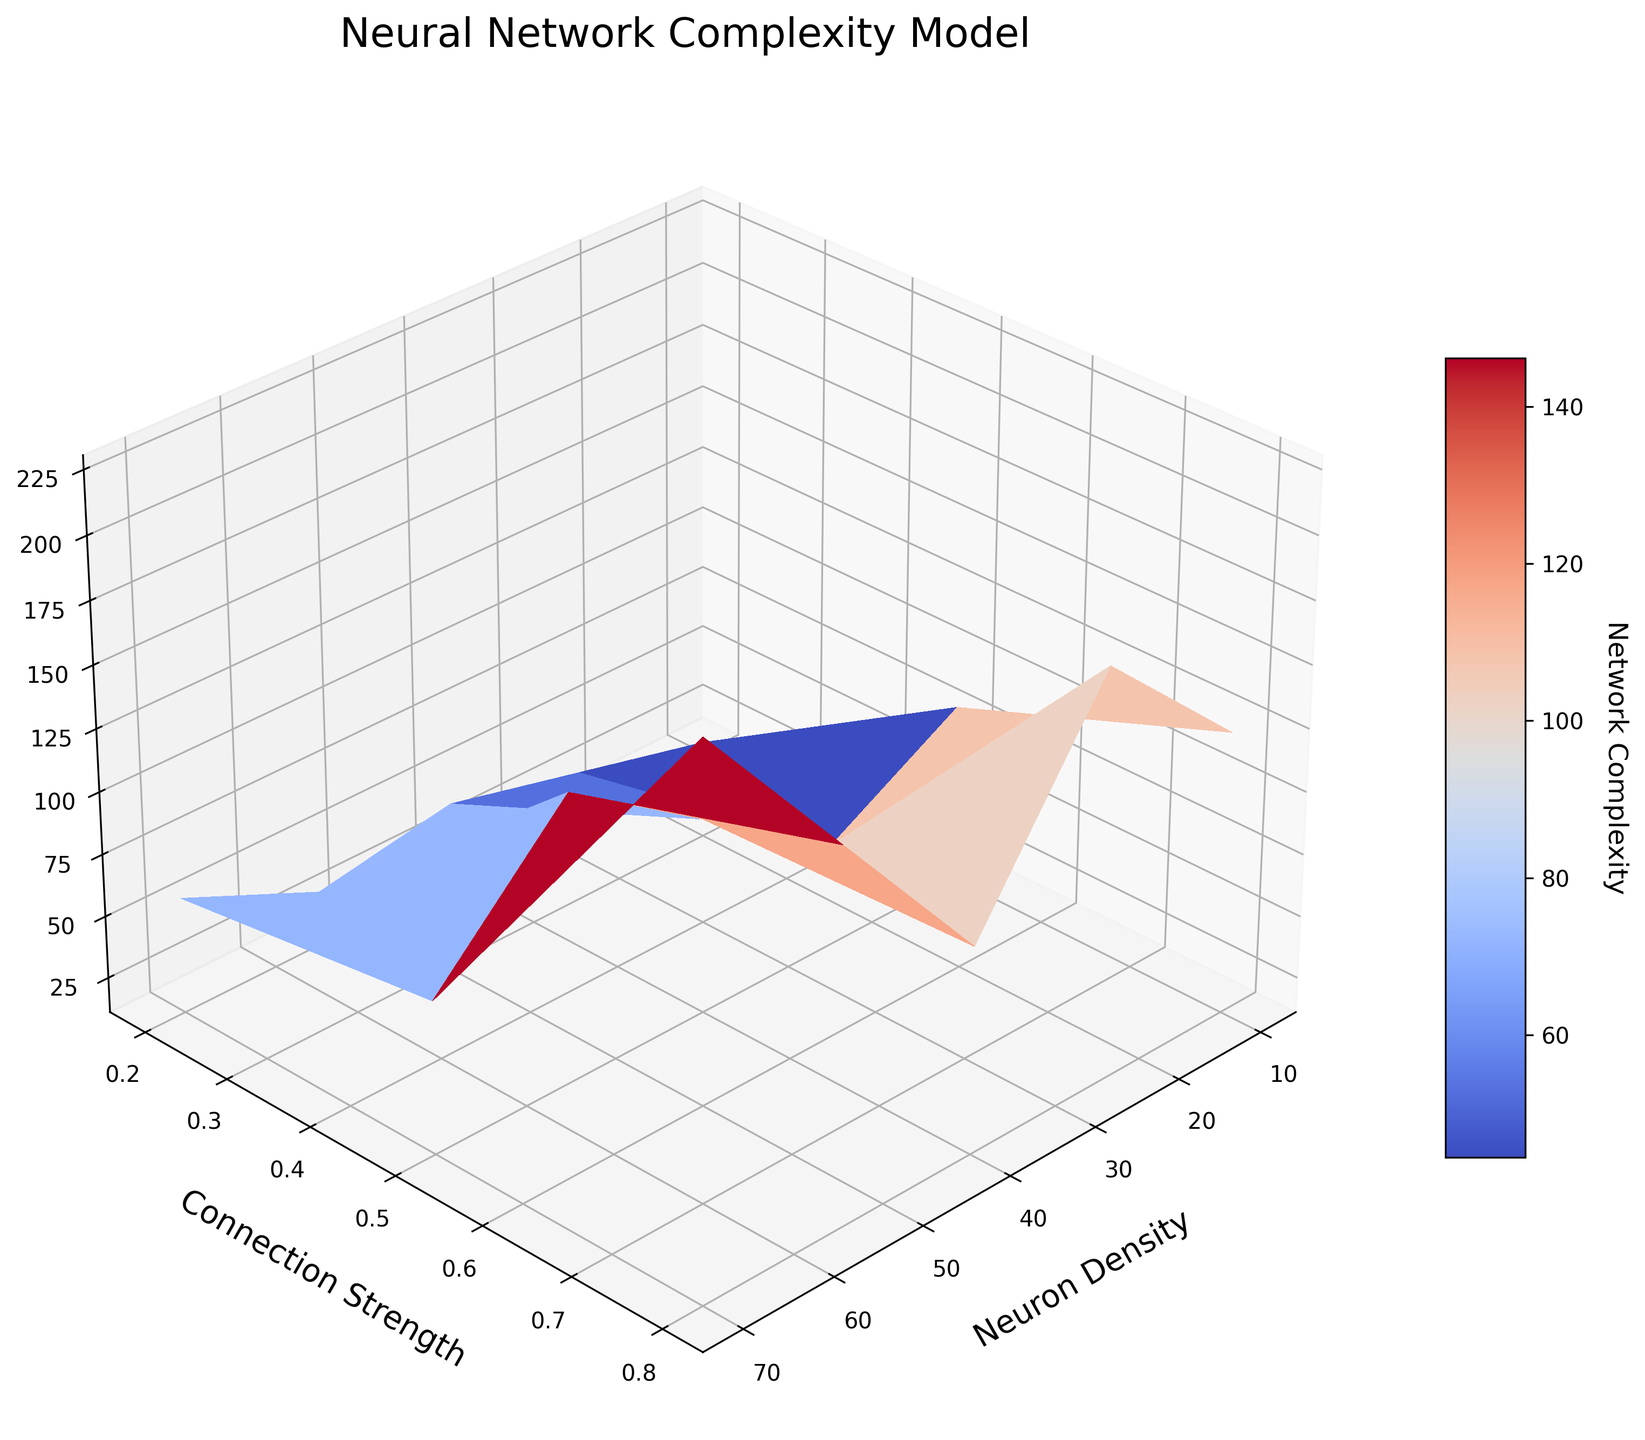What is the title of the figure? The title of a figure is usually displayed prominently at the top of the plot. Here, it reads 'Neural Network Complexity Model' as stated in the code.
Answer: Neural Network Complexity Model What do the X, Y, and Z axes represent in the plot? The axes are labeled. The X axis is labeled 'Neuron Density', the Y axis is labeled 'Connection Strength', and the Z axis is labeled 'Network Complexity'.
Answer: Neuron Density, Connection Strength, Network Complexity Which combination of Neuron Density and Connection Strength results in the highest Network Complexity? By examining the surface plot's highest value, the combination (70, 0.8) yields the highest Network Complexity, indicated by the peak at these coordinates.
Answer: (70, 0.8) How does increasing the Neuron Density, while keeping the Connection Strength constant, affect the Network Complexity? Observe the surface plot's elevation changes along the X direction while keeping Y constant. The plot shows that Network Complexity increases with Neuron Density at a constant Connection Strength.
Answer: It increases Network Complexity For a Neuron Density of 55, what is the difference in Network Complexity between Connection Strengths 0.2 and 0.8? Look at the two points with Neuron Density = 55 and different Connection Strengths. The values are 175.2 (CS=0.8) - 72.1 (CS=0.2) = 103.1.
Answer: 103.1 What is the trend of Network Complexity when Connection Strength increases from 0.2 to 0.8 for a fixed Neuron Density? By moving along the Y axis for fixed X values, it's visible that Network Complexity increases as Connection Strength goes from 0.2 to 0.8 across all Neuron Density values.
Answer: It increases If the Neuron Density is 25, what is the average Network Complexity across all Connection Strengths? The Network Complexity values for Neuron Density of 25 are 32.6, 57.4, and 81.9. The average is (32.6 + 57.4 + 81.9) / 3 = 57.3.
Answer: 57.3 At what viewing angles are the 3D surface plot rendered? The provided code specifies the viewing angles as 'elev=30' and 'azim=45', indicating the plot is viewed from 30 degrees elevation and 45 degrees azimuth.
Answer: elev=30, azim=45 